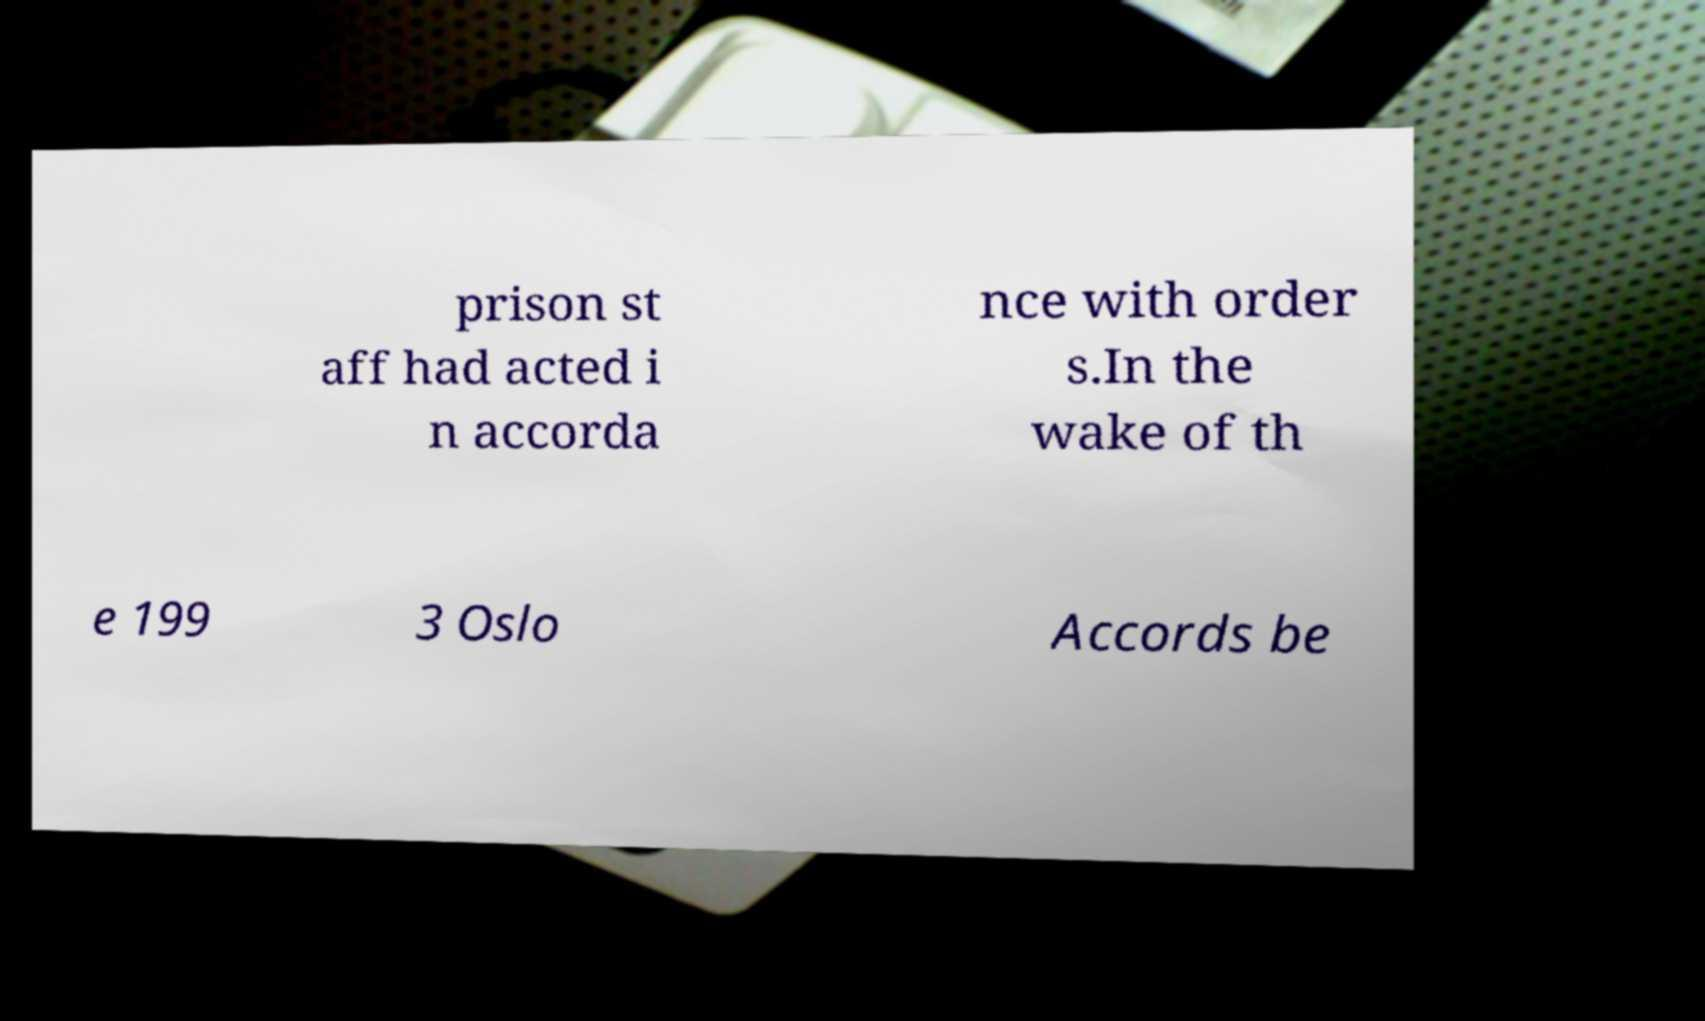Please identify and transcribe the text found in this image. prison st aff had acted i n accorda nce with order s.In the wake of th e 199 3 Oslo Accords be 